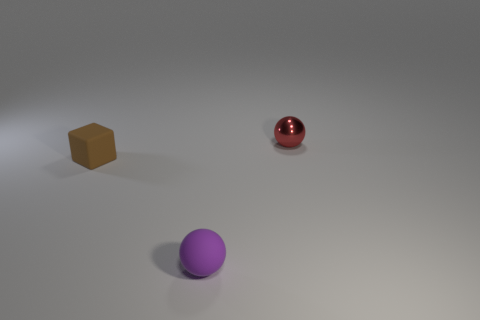Assuming the objects are related, what story or context could you imagine for this composition? One could imagine a setting where these objects represent different characters or elements in a minimalist story—perhaps the vibrant red sphere is a rare treasure, the purple sphere is the guardian, and the small tan cube is the key to unlocking a hidden secret within the scene. 